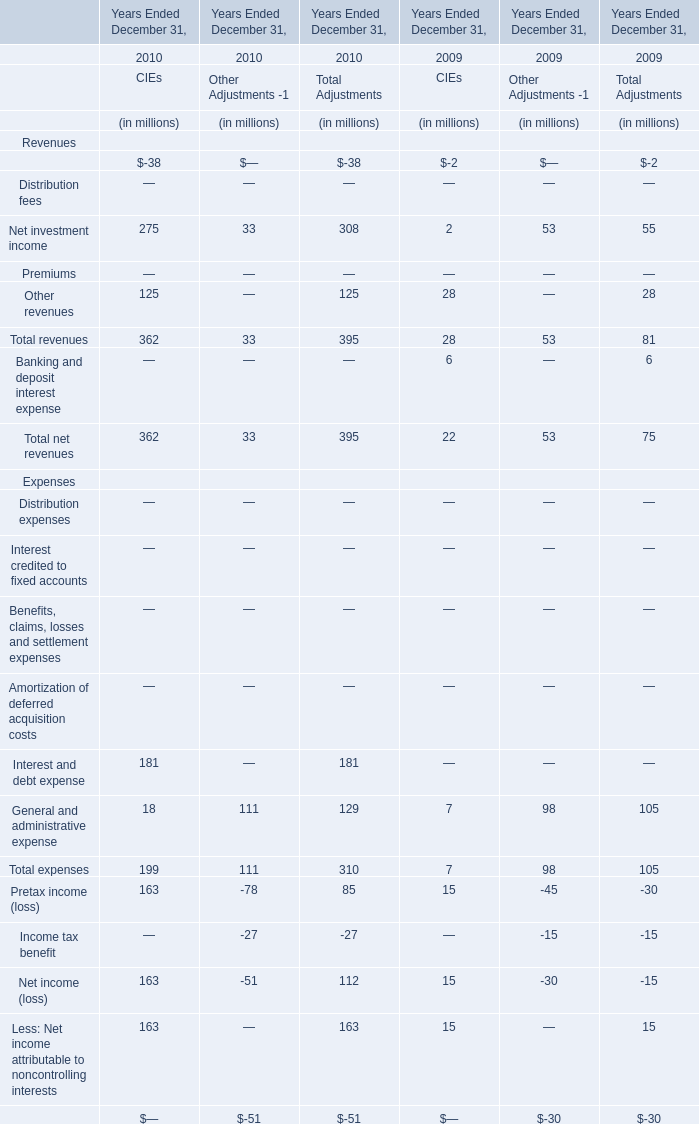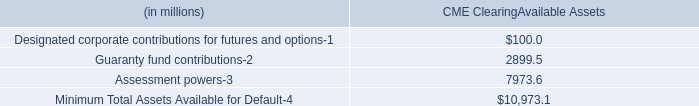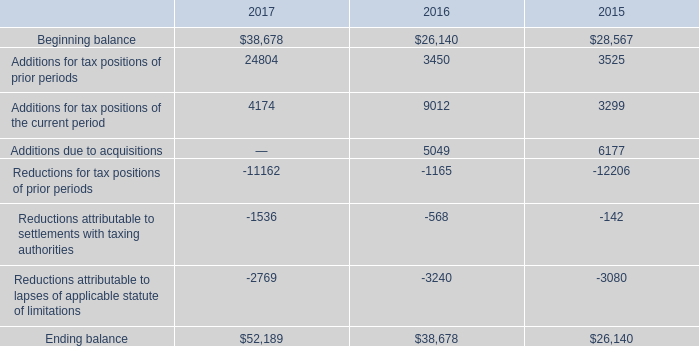by what percentage can cme increase their current line of credit? 
Computations: ((7 - 5) / 5)
Answer: 0.4. 